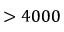Convert formula to latex. <formula><loc_0><loc_0><loc_500><loc_500>> 4 0 0 0</formula> 